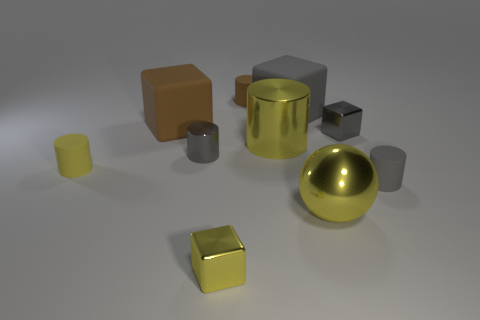Subtract all brown cylinders. How many cylinders are left? 4 Subtract 2 cylinders. How many cylinders are left? 3 Subtract all large yellow cylinders. How many cylinders are left? 4 Subtract all purple cylinders. Subtract all blue spheres. How many cylinders are left? 5 Subtract all balls. How many objects are left? 9 Add 1 tiny gray metallic blocks. How many tiny gray metallic blocks exist? 2 Subtract 0 purple spheres. How many objects are left? 10 Subtract all large cyan shiny blocks. Subtract all gray metal things. How many objects are left? 8 Add 4 gray matte objects. How many gray matte objects are left? 6 